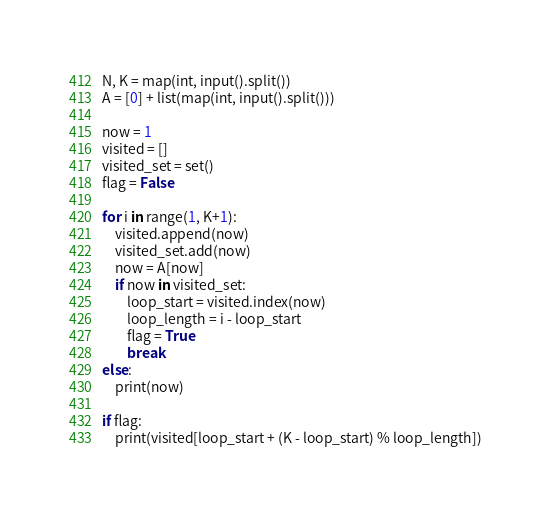Convert code to text. <code><loc_0><loc_0><loc_500><loc_500><_Python_>N, K = map(int, input().split())
A = [0] + list(map(int, input().split()))

now = 1
visited = []
visited_set = set()
flag = False

for i in range(1, K+1):
    visited.append(now)
    visited_set.add(now)
    now = A[now]
    if now in visited_set:
        loop_start = visited.index(now)
        loop_length = i - loop_start
        flag = True
        break
else:
    print(now)

if flag:
    print(visited[loop_start + (K - loop_start) % loop_length])
</code> 